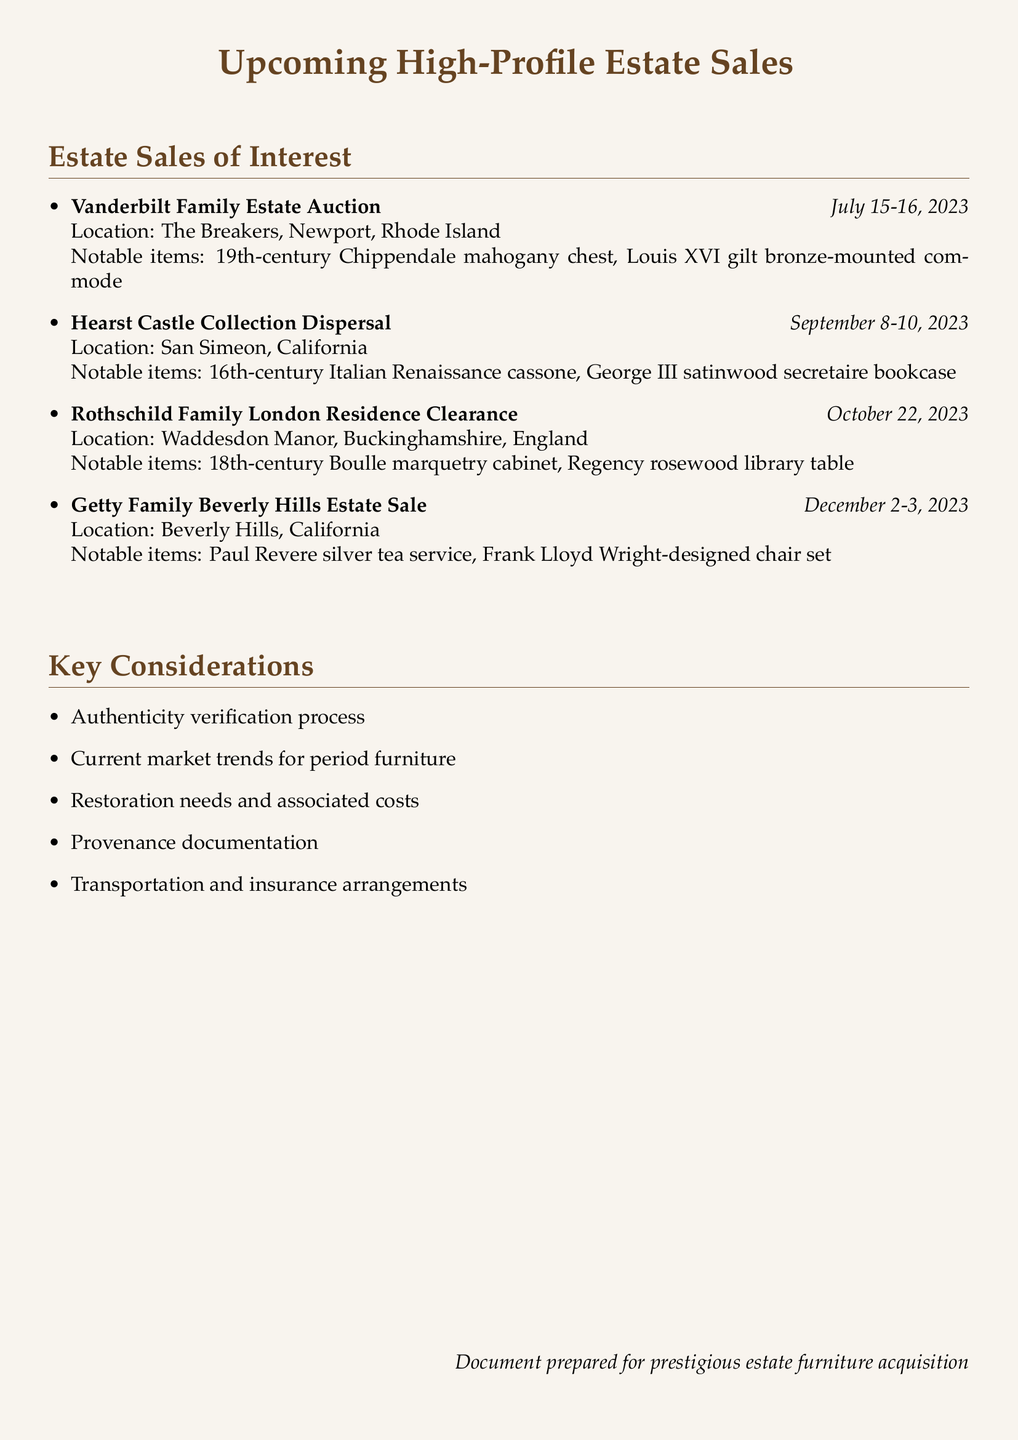What is the date of the Vanderbilt Family Estate Auction? The date is specified directly in the document as July 15-16, 2023.
Answer: July 15-16, 2023 Where is the Getty Family Beverly Hills Estate Sale located? The location is clearly mentioned in the document as Beverly Hills, California.
Answer: Beverly Hills, California What is one notable item from the Hearst Castle Collection Dispersal? The document lists several notable items, one of which is the 16th-century Italian Renaissance cassone.
Answer: 16th-century Italian Renaissance cassone How many estate sales are listed in total? There are four different estate sales mentioned in the document.
Answer: Four What is a key consideration for furniture acquisition as mentioned in the document? The document lists several key considerations, one being the authenticity verification process.
Answer: Authenticity verification process Which estate sale occurs last by date? The last estate sale by date mentioned in the document is the Getty Family Beverly Hills Estate Sale.
Answer: Getty Family Beverly Hills Estate Sale How many notable items are listed for the Rothschild Family London Residence Clearance? The document specifies three notable items for this estate sale.
Answer: Three In which country is the Rothschild Family London Residence located? The location is indicated as Waddesdon Manor, Buckinghamshire, England.
Answer: England What type of document is this? The document is a list detailing upcoming high-profile estate sales and considerations for furniture acquisition.
Answer: Estate sales notes 